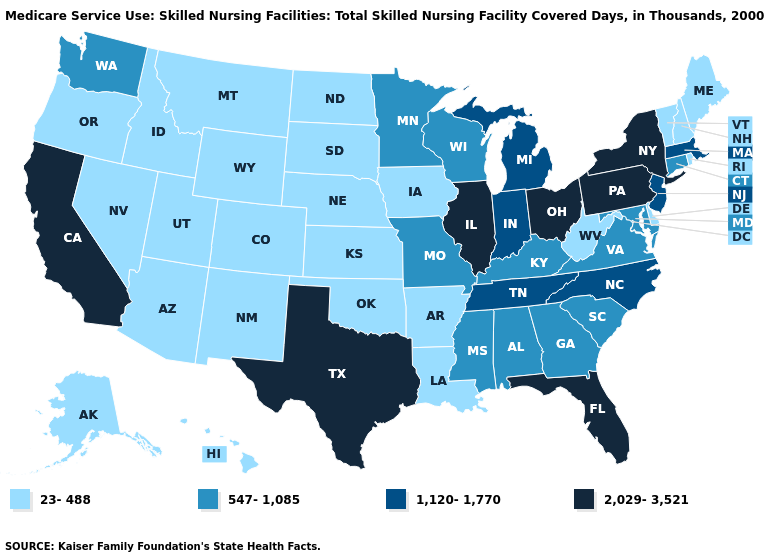Does the map have missing data?
Concise answer only. No. What is the highest value in states that border Utah?
Write a very short answer. 23-488. Does Virginia have the same value as Alabama?
Quick response, please. Yes. What is the highest value in the West ?
Write a very short answer. 2,029-3,521. Does Maryland have a lower value than Missouri?
Quick response, please. No. Name the states that have a value in the range 23-488?
Be succinct. Alaska, Arizona, Arkansas, Colorado, Delaware, Hawaii, Idaho, Iowa, Kansas, Louisiana, Maine, Montana, Nebraska, Nevada, New Hampshire, New Mexico, North Dakota, Oklahoma, Oregon, Rhode Island, South Dakota, Utah, Vermont, West Virginia, Wyoming. Which states have the lowest value in the West?
Give a very brief answer. Alaska, Arizona, Colorado, Hawaii, Idaho, Montana, Nevada, New Mexico, Oregon, Utah, Wyoming. Which states have the highest value in the USA?
Give a very brief answer. California, Florida, Illinois, New York, Ohio, Pennsylvania, Texas. What is the value of Virginia?
Quick response, please. 547-1,085. What is the value of Ohio?
Quick response, please. 2,029-3,521. Does Indiana have the lowest value in the MidWest?
Concise answer only. No. Does Nevada have a higher value than North Dakota?
Answer briefly. No. Does South Carolina have the lowest value in the USA?
Write a very short answer. No. Which states have the highest value in the USA?
Answer briefly. California, Florida, Illinois, New York, Ohio, Pennsylvania, Texas. 